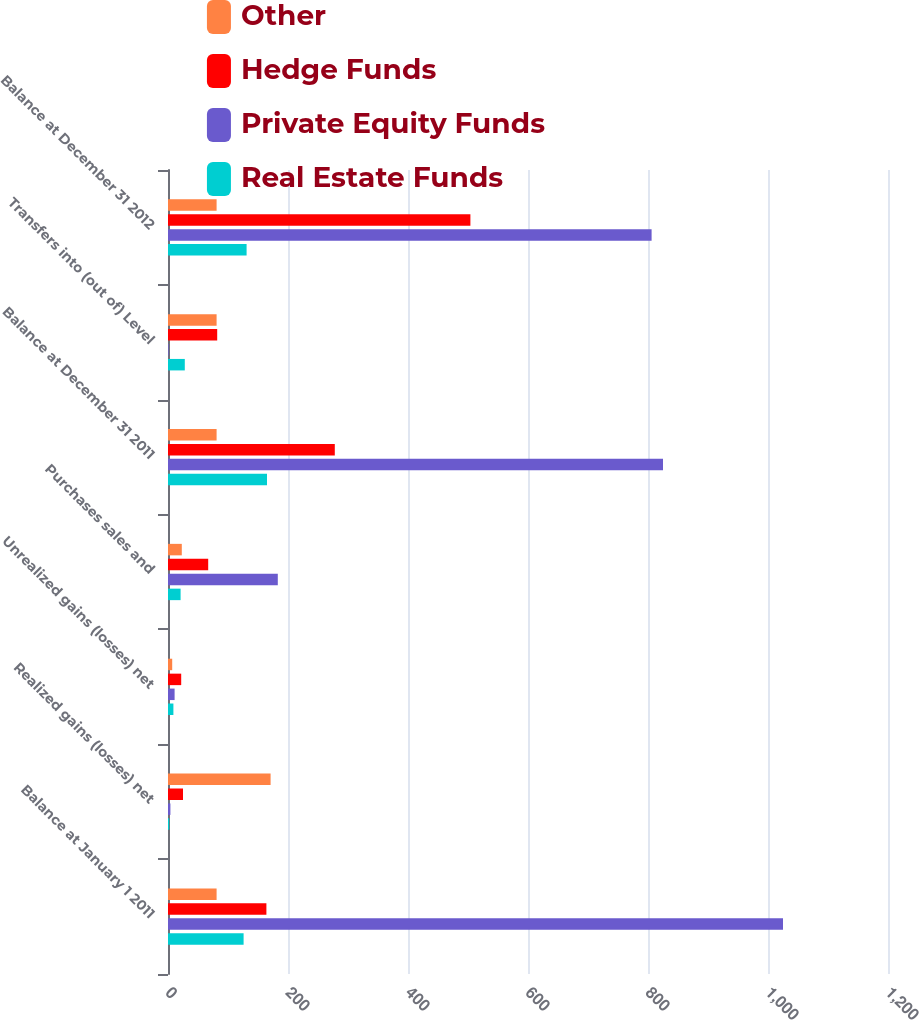<chart> <loc_0><loc_0><loc_500><loc_500><stacked_bar_chart><ecel><fcel>Balance at January 1 2011<fcel>Realized gains (losses) net<fcel>Unrealized gains (losses) net<fcel>Purchases sales and<fcel>Balance at December 31 2011<fcel>Transfers into (out of) Level<fcel>Balance at December 31 2012<nl><fcel>Other<fcel>81<fcel>171<fcel>7<fcel>23<fcel>81<fcel>81<fcel>81<nl><fcel>Hedge Funds<fcel>164<fcel>25<fcel>22<fcel>67<fcel>278<fcel>82<fcel>504<nl><fcel>Private Equity Funds<fcel>1025<fcel>4<fcel>11<fcel>183<fcel>825<fcel>1<fcel>806<nl><fcel>Real Estate Funds<fcel>126<fcel>2<fcel>9<fcel>21<fcel>165<fcel>28<fcel>131<nl></chart> 